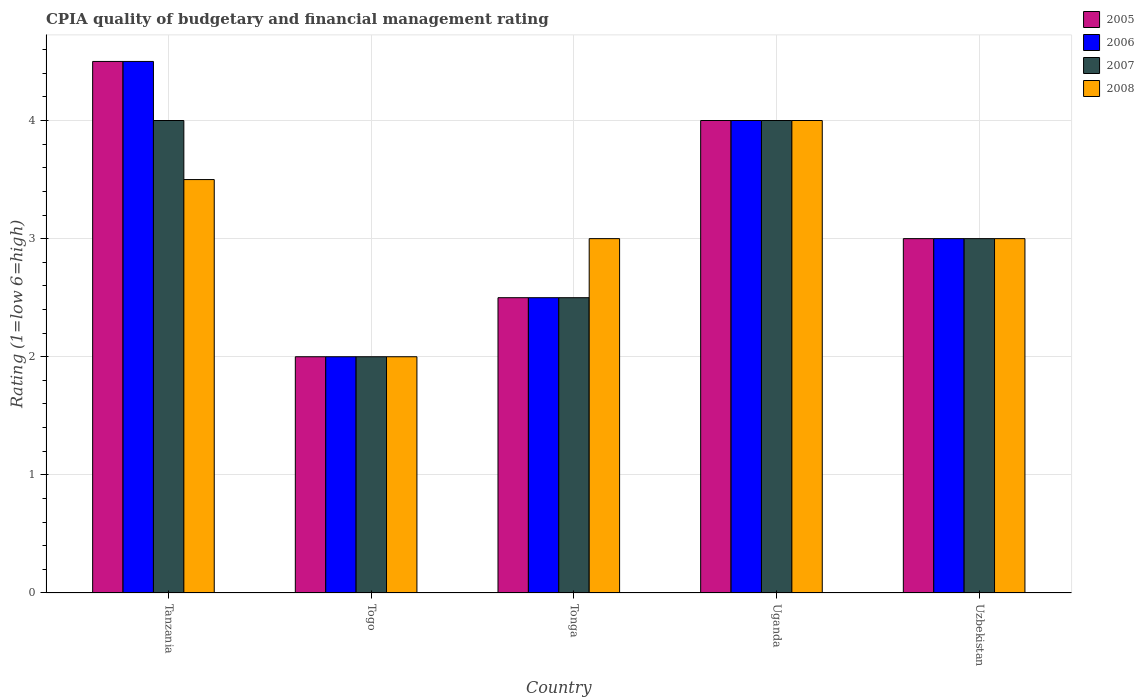How many groups of bars are there?
Offer a terse response. 5. Are the number of bars per tick equal to the number of legend labels?
Offer a terse response. Yes. What is the label of the 2nd group of bars from the left?
Provide a short and direct response. Togo. In how many cases, is the number of bars for a given country not equal to the number of legend labels?
Your answer should be compact. 0. What is the CPIA rating in 2005 in Togo?
Provide a short and direct response. 2. Across all countries, what is the maximum CPIA rating in 2007?
Offer a very short reply. 4. In which country was the CPIA rating in 2006 maximum?
Your answer should be very brief. Tanzania. In which country was the CPIA rating in 2008 minimum?
Keep it short and to the point. Togo. What is the total CPIA rating in 2005 in the graph?
Provide a short and direct response. 16. What is the difference between the CPIA rating of/in 2008 and CPIA rating of/in 2006 in Togo?
Ensure brevity in your answer.  0. In how many countries, is the CPIA rating in 2007 greater than 1.4?
Give a very brief answer. 5. Is the difference between the CPIA rating in 2008 in Tonga and Uzbekistan greater than the difference between the CPIA rating in 2006 in Tonga and Uzbekistan?
Your answer should be compact. Yes. Is the sum of the CPIA rating in 2008 in Tanzania and Uzbekistan greater than the maximum CPIA rating in 2007 across all countries?
Provide a short and direct response. Yes. Is it the case that in every country, the sum of the CPIA rating in 2005 and CPIA rating in 2007 is greater than the sum of CPIA rating in 2008 and CPIA rating in 2006?
Your answer should be very brief. No. What does the 1st bar from the left in Togo represents?
Offer a terse response. 2005. What does the 4th bar from the right in Uganda represents?
Your answer should be very brief. 2005. Are all the bars in the graph horizontal?
Keep it short and to the point. No. How many countries are there in the graph?
Your response must be concise. 5. Does the graph contain any zero values?
Offer a terse response. No. How many legend labels are there?
Your answer should be compact. 4. How are the legend labels stacked?
Your answer should be very brief. Vertical. What is the title of the graph?
Provide a succinct answer. CPIA quality of budgetary and financial management rating. What is the label or title of the Y-axis?
Your response must be concise. Rating (1=low 6=high). What is the Rating (1=low 6=high) in 2005 in Togo?
Offer a terse response. 2. What is the Rating (1=low 6=high) of 2006 in Togo?
Make the answer very short. 2. What is the Rating (1=low 6=high) in 2007 in Togo?
Ensure brevity in your answer.  2. What is the Rating (1=low 6=high) in 2006 in Tonga?
Provide a short and direct response. 2.5. What is the Rating (1=low 6=high) of 2008 in Tonga?
Offer a terse response. 3. What is the Rating (1=low 6=high) of 2005 in Uganda?
Offer a terse response. 4. What is the Rating (1=low 6=high) of 2007 in Uganda?
Provide a short and direct response. 4. What is the Rating (1=low 6=high) in 2008 in Uganda?
Provide a short and direct response. 4. What is the Rating (1=low 6=high) in 2005 in Uzbekistan?
Offer a terse response. 3. What is the Rating (1=low 6=high) in 2006 in Uzbekistan?
Your answer should be very brief. 3. What is the Rating (1=low 6=high) of 2007 in Uzbekistan?
Ensure brevity in your answer.  3. Across all countries, what is the maximum Rating (1=low 6=high) of 2008?
Offer a very short reply. 4. Across all countries, what is the minimum Rating (1=low 6=high) in 2005?
Keep it short and to the point. 2. Across all countries, what is the minimum Rating (1=low 6=high) in 2006?
Offer a terse response. 2. What is the total Rating (1=low 6=high) of 2005 in the graph?
Ensure brevity in your answer.  16. What is the total Rating (1=low 6=high) of 2007 in the graph?
Your answer should be very brief. 15.5. What is the total Rating (1=low 6=high) of 2008 in the graph?
Provide a short and direct response. 15.5. What is the difference between the Rating (1=low 6=high) of 2006 in Tanzania and that in Togo?
Make the answer very short. 2.5. What is the difference between the Rating (1=low 6=high) of 2007 in Tanzania and that in Togo?
Make the answer very short. 2. What is the difference between the Rating (1=low 6=high) of 2008 in Tanzania and that in Togo?
Your answer should be compact. 1.5. What is the difference between the Rating (1=low 6=high) of 2005 in Tanzania and that in Tonga?
Ensure brevity in your answer.  2. What is the difference between the Rating (1=low 6=high) in 2005 in Tanzania and that in Uganda?
Make the answer very short. 0.5. What is the difference between the Rating (1=low 6=high) in 2007 in Tanzania and that in Uganda?
Keep it short and to the point. 0. What is the difference between the Rating (1=low 6=high) in 2005 in Tanzania and that in Uzbekistan?
Make the answer very short. 1.5. What is the difference between the Rating (1=low 6=high) of 2007 in Tanzania and that in Uzbekistan?
Offer a terse response. 1. What is the difference between the Rating (1=low 6=high) in 2005 in Togo and that in Tonga?
Keep it short and to the point. -0.5. What is the difference between the Rating (1=low 6=high) in 2006 in Togo and that in Tonga?
Offer a very short reply. -0.5. What is the difference between the Rating (1=low 6=high) in 2007 in Togo and that in Tonga?
Provide a short and direct response. -0.5. What is the difference between the Rating (1=low 6=high) of 2005 in Togo and that in Uganda?
Your answer should be very brief. -2. What is the difference between the Rating (1=low 6=high) of 2006 in Togo and that in Uganda?
Make the answer very short. -2. What is the difference between the Rating (1=low 6=high) in 2007 in Togo and that in Uganda?
Your answer should be very brief. -2. What is the difference between the Rating (1=low 6=high) of 2008 in Togo and that in Uzbekistan?
Offer a terse response. -1. What is the difference between the Rating (1=low 6=high) in 2005 in Tonga and that in Uganda?
Your answer should be compact. -1.5. What is the difference between the Rating (1=low 6=high) in 2008 in Tonga and that in Uganda?
Offer a terse response. -1. What is the difference between the Rating (1=low 6=high) in 2008 in Tonga and that in Uzbekistan?
Give a very brief answer. 0. What is the difference between the Rating (1=low 6=high) in 2006 in Uganda and that in Uzbekistan?
Offer a terse response. 1. What is the difference between the Rating (1=low 6=high) in 2008 in Uganda and that in Uzbekistan?
Ensure brevity in your answer.  1. What is the difference between the Rating (1=low 6=high) in 2005 in Tanzania and the Rating (1=low 6=high) in 2007 in Togo?
Make the answer very short. 2.5. What is the difference between the Rating (1=low 6=high) of 2005 in Tanzania and the Rating (1=low 6=high) of 2008 in Togo?
Give a very brief answer. 2.5. What is the difference between the Rating (1=low 6=high) of 2006 in Tanzania and the Rating (1=low 6=high) of 2007 in Togo?
Ensure brevity in your answer.  2.5. What is the difference between the Rating (1=low 6=high) in 2006 in Tanzania and the Rating (1=low 6=high) in 2008 in Togo?
Give a very brief answer. 2.5. What is the difference between the Rating (1=low 6=high) in 2005 in Tanzania and the Rating (1=low 6=high) in 2006 in Tonga?
Your response must be concise. 2. What is the difference between the Rating (1=low 6=high) of 2005 in Tanzania and the Rating (1=low 6=high) of 2008 in Tonga?
Offer a terse response. 1.5. What is the difference between the Rating (1=low 6=high) in 2005 in Tanzania and the Rating (1=low 6=high) in 2006 in Uganda?
Give a very brief answer. 0.5. What is the difference between the Rating (1=low 6=high) in 2005 in Tanzania and the Rating (1=low 6=high) in 2007 in Uganda?
Your answer should be very brief. 0.5. What is the difference between the Rating (1=low 6=high) of 2005 in Tanzania and the Rating (1=low 6=high) of 2007 in Uzbekistan?
Ensure brevity in your answer.  1.5. What is the difference between the Rating (1=low 6=high) in 2006 in Tanzania and the Rating (1=low 6=high) in 2007 in Uzbekistan?
Give a very brief answer. 1.5. What is the difference between the Rating (1=low 6=high) of 2007 in Tanzania and the Rating (1=low 6=high) of 2008 in Uzbekistan?
Offer a terse response. 1. What is the difference between the Rating (1=low 6=high) of 2005 in Togo and the Rating (1=low 6=high) of 2007 in Tonga?
Offer a very short reply. -0.5. What is the difference between the Rating (1=low 6=high) in 2005 in Togo and the Rating (1=low 6=high) in 2008 in Tonga?
Provide a succinct answer. -1. What is the difference between the Rating (1=low 6=high) of 2005 in Togo and the Rating (1=low 6=high) of 2007 in Uganda?
Ensure brevity in your answer.  -2. What is the difference between the Rating (1=low 6=high) in 2007 in Togo and the Rating (1=low 6=high) in 2008 in Uganda?
Provide a short and direct response. -2. What is the difference between the Rating (1=low 6=high) of 2005 in Togo and the Rating (1=low 6=high) of 2007 in Uzbekistan?
Your answer should be compact. -1. What is the difference between the Rating (1=low 6=high) of 2006 in Togo and the Rating (1=low 6=high) of 2008 in Uzbekistan?
Give a very brief answer. -1. What is the difference between the Rating (1=low 6=high) of 2007 in Togo and the Rating (1=low 6=high) of 2008 in Uzbekistan?
Give a very brief answer. -1. What is the difference between the Rating (1=low 6=high) of 2005 in Tonga and the Rating (1=low 6=high) of 2008 in Uganda?
Offer a terse response. -1.5. What is the difference between the Rating (1=low 6=high) in 2007 in Tonga and the Rating (1=low 6=high) in 2008 in Uganda?
Provide a short and direct response. -1.5. What is the difference between the Rating (1=low 6=high) in 2005 in Tonga and the Rating (1=low 6=high) in 2006 in Uzbekistan?
Keep it short and to the point. -0.5. What is the difference between the Rating (1=low 6=high) in 2005 in Tonga and the Rating (1=low 6=high) in 2007 in Uzbekistan?
Offer a very short reply. -0.5. What is the difference between the Rating (1=low 6=high) of 2006 in Tonga and the Rating (1=low 6=high) of 2007 in Uzbekistan?
Offer a terse response. -0.5. What is the difference between the Rating (1=low 6=high) of 2005 in Uganda and the Rating (1=low 6=high) of 2006 in Uzbekistan?
Offer a terse response. 1. What is the difference between the Rating (1=low 6=high) of 2005 in Uganda and the Rating (1=low 6=high) of 2008 in Uzbekistan?
Your answer should be compact. 1. What is the difference between the Rating (1=low 6=high) of 2006 in Uganda and the Rating (1=low 6=high) of 2007 in Uzbekistan?
Your answer should be very brief. 1. What is the difference between the Rating (1=low 6=high) in 2007 in Uganda and the Rating (1=low 6=high) in 2008 in Uzbekistan?
Keep it short and to the point. 1. What is the average Rating (1=low 6=high) in 2008 per country?
Keep it short and to the point. 3.1. What is the difference between the Rating (1=low 6=high) in 2005 and Rating (1=low 6=high) in 2007 in Tanzania?
Give a very brief answer. 0.5. What is the difference between the Rating (1=low 6=high) in 2006 and Rating (1=low 6=high) in 2008 in Tanzania?
Ensure brevity in your answer.  1. What is the difference between the Rating (1=low 6=high) of 2007 and Rating (1=low 6=high) of 2008 in Tanzania?
Your answer should be very brief. 0.5. What is the difference between the Rating (1=low 6=high) of 2006 and Rating (1=low 6=high) of 2007 in Togo?
Provide a short and direct response. 0. What is the difference between the Rating (1=low 6=high) in 2006 and Rating (1=low 6=high) in 2008 in Togo?
Offer a very short reply. 0. What is the difference between the Rating (1=low 6=high) in 2005 and Rating (1=low 6=high) in 2006 in Tonga?
Offer a terse response. 0. What is the difference between the Rating (1=low 6=high) of 2005 and Rating (1=low 6=high) of 2008 in Tonga?
Provide a short and direct response. -0.5. What is the difference between the Rating (1=low 6=high) of 2006 and Rating (1=low 6=high) of 2008 in Tonga?
Give a very brief answer. -0.5. What is the difference between the Rating (1=low 6=high) of 2007 and Rating (1=low 6=high) of 2008 in Tonga?
Make the answer very short. -0.5. What is the difference between the Rating (1=low 6=high) in 2005 and Rating (1=low 6=high) in 2008 in Uganda?
Ensure brevity in your answer.  0. What is the difference between the Rating (1=low 6=high) in 2005 and Rating (1=low 6=high) in 2006 in Uzbekistan?
Make the answer very short. 0. What is the difference between the Rating (1=low 6=high) in 2005 and Rating (1=low 6=high) in 2007 in Uzbekistan?
Your answer should be compact. 0. What is the difference between the Rating (1=low 6=high) in 2005 and Rating (1=low 6=high) in 2008 in Uzbekistan?
Provide a succinct answer. 0. What is the difference between the Rating (1=low 6=high) of 2006 and Rating (1=low 6=high) of 2008 in Uzbekistan?
Keep it short and to the point. 0. What is the difference between the Rating (1=low 6=high) of 2007 and Rating (1=low 6=high) of 2008 in Uzbekistan?
Your answer should be very brief. 0. What is the ratio of the Rating (1=low 6=high) in 2005 in Tanzania to that in Togo?
Provide a succinct answer. 2.25. What is the ratio of the Rating (1=low 6=high) of 2006 in Tanzania to that in Togo?
Provide a short and direct response. 2.25. What is the ratio of the Rating (1=low 6=high) of 2007 in Tanzania to that in Togo?
Offer a very short reply. 2. What is the ratio of the Rating (1=low 6=high) of 2005 in Tanzania to that in Tonga?
Make the answer very short. 1.8. What is the ratio of the Rating (1=low 6=high) of 2007 in Tanzania to that in Tonga?
Provide a succinct answer. 1.6. What is the ratio of the Rating (1=low 6=high) in 2008 in Tanzania to that in Tonga?
Provide a succinct answer. 1.17. What is the ratio of the Rating (1=low 6=high) of 2007 in Tanzania to that in Uganda?
Provide a succinct answer. 1. What is the ratio of the Rating (1=low 6=high) of 2008 in Tanzania to that in Uganda?
Your response must be concise. 0.88. What is the ratio of the Rating (1=low 6=high) in 2007 in Tanzania to that in Uzbekistan?
Your answer should be very brief. 1.33. What is the ratio of the Rating (1=low 6=high) in 2005 in Togo to that in Tonga?
Ensure brevity in your answer.  0.8. What is the ratio of the Rating (1=low 6=high) in 2006 in Togo to that in Tonga?
Your answer should be very brief. 0.8. What is the ratio of the Rating (1=low 6=high) of 2008 in Togo to that in Tonga?
Make the answer very short. 0.67. What is the ratio of the Rating (1=low 6=high) of 2005 in Togo to that in Uganda?
Your answer should be very brief. 0.5. What is the ratio of the Rating (1=low 6=high) in 2005 in Togo to that in Uzbekistan?
Offer a terse response. 0.67. What is the ratio of the Rating (1=low 6=high) of 2007 in Togo to that in Uzbekistan?
Give a very brief answer. 0.67. What is the ratio of the Rating (1=low 6=high) of 2005 in Tonga to that in Uganda?
Give a very brief answer. 0.62. What is the ratio of the Rating (1=low 6=high) of 2007 in Tonga to that in Uganda?
Give a very brief answer. 0.62. What is the ratio of the Rating (1=low 6=high) in 2008 in Tonga to that in Uganda?
Provide a short and direct response. 0.75. What is the ratio of the Rating (1=low 6=high) in 2007 in Tonga to that in Uzbekistan?
Offer a terse response. 0.83. What is the ratio of the Rating (1=low 6=high) in 2008 in Tonga to that in Uzbekistan?
Offer a terse response. 1. What is the ratio of the Rating (1=low 6=high) in 2008 in Uganda to that in Uzbekistan?
Your answer should be compact. 1.33. What is the difference between the highest and the second highest Rating (1=low 6=high) of 2006?
Give a very brief answer. 0.5. What is the difference between the highest and the second highest Rating (1=low 6=high) of 2007?
Your response must be concise. 0. What is the difference between the highest and the lowest Rating (1=low 6=high) of 2006?
Your answer should be very brief. 2.5. What is the difference between the highest and the lowest Rating (1=low 6=high) in 2007?
Give a very brief answer. 2. 